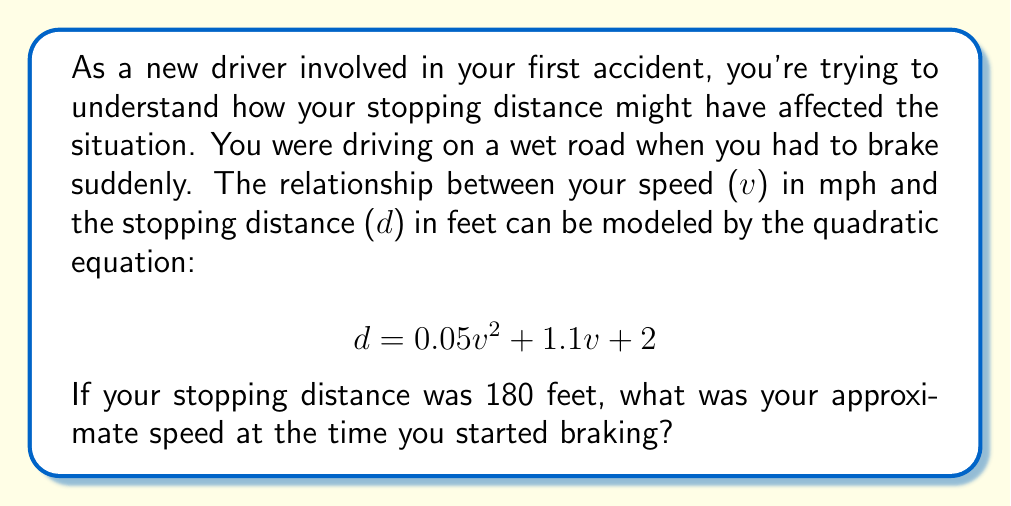Teach me how to tackle this problem. To solve this problem, we need to use the quadratic formula since we're given a quadratic equation and need to solve for v.

1) First, let's rearrange the equation to standard form $(av^2 + bv + c = 0)$:

   $0.05v^2 + 1.1v + 2 - 180 = 0$
   $0.05v^2 + 1.1v - 178 = 0$

2) Now we can identify a, b, and c:
   $a = 0.05$
   $b = 1.1$
   $c = -178$

3) The quadratic formula is:

   $$ v = \frac{-b \pm \sqrt{b^2 - 4ac}}{2a} $$

4) Let's substitute our values:

   $$ v = \frac{-1.1 \pm \sqrt{1.1^2 - 4(0.05)(-178)}}{2(0.05)} $$

5) Simplify under the square root:

   $$ v = \frac{-1.1 \pm \sqrt{1.21 + 35.6}}{0.1} = \frac{-1.1 \pm \sqrt{36.81}}{0.1} $$

6) Simplify further:

   $$ v = \frac{-1.1 \pm 6.07}{0.1} $$

7) This gives us two solutions:

   $$ v = \frac{-1.1 + 6.07}{0.1} = 49.7 \quad \text{or} \quad v = \frac{-1.1 - 6.07}{0.1} = -71.7 $$

8) Since speed can't be negative, we discard the negative solution.

Therefore, the speed was approximately 49.7 mph.
Answer: The approximate speed at the time of braking was 49.7 mph. 